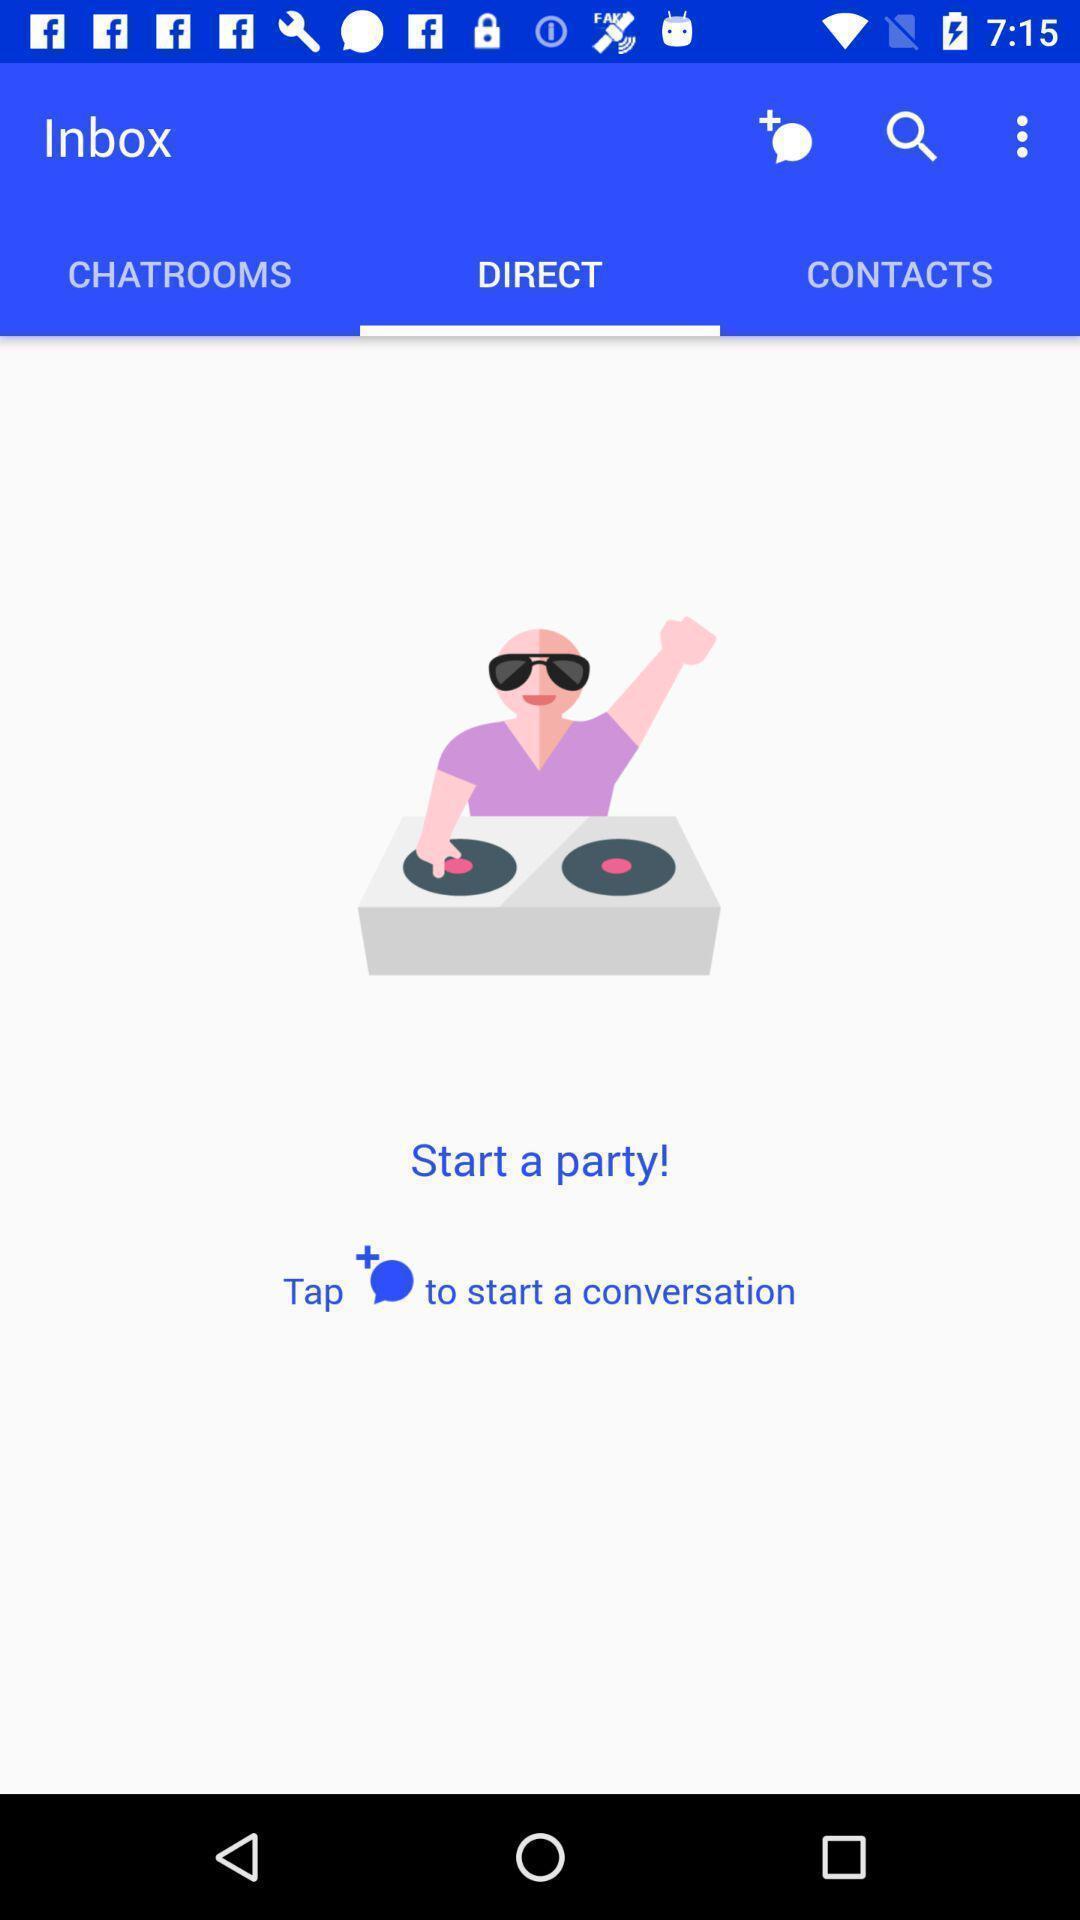Please provide a description for this image. Page is showing tap to start conversation. 